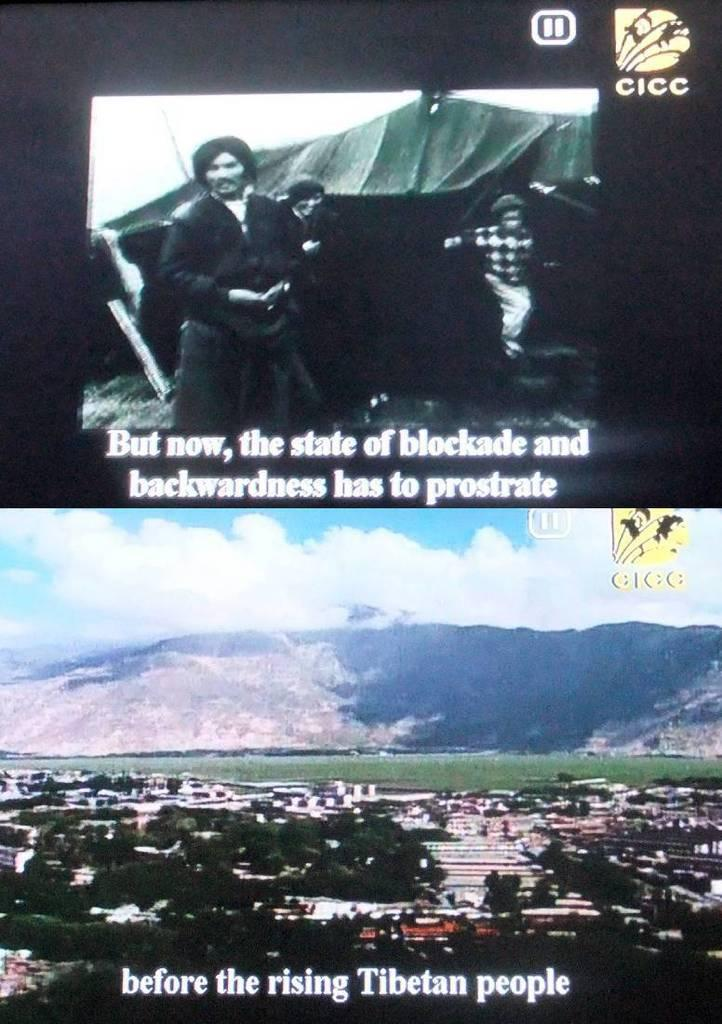Provide a one-sentence caption for the provided image. Two screen shots out the state of blockade before the rising of the Tibetan people. 